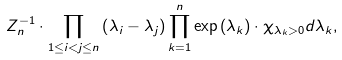Convert formula to latex. <formula><loc_0><loc_0><loc_500><loc_500>Z _ { n } ^ { - 1 } \cdot \prod _ { 1 \leq { i } < j \leq { n } } \left ( \lambda _ { i } - \lambda _ { j } \right ) \prod _ { k = 1 } ^ { n } \exp \left ( \lambda _ { k } \right ) \cdot \chi _ { \lambda _ { k } > 0 } d \lambda _ { k } ,</formula> 